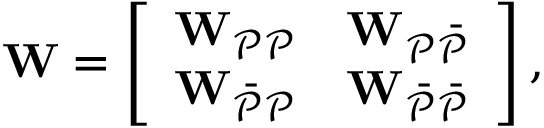<formula> <loc_0><loc_0><loc_500><loc_500>W = \left [ \begin{array} { l l } { W _ { \mathcal { P P } } } & { W _ { \mathcal { P \ B a r { P } } } } \\ { W _ { \mathcal { \ B a r { P } P } } } & { W _ { \mathcal { \ B a r { P } \ B a r { P } } } } \end{array} \right ] ,</formula> 